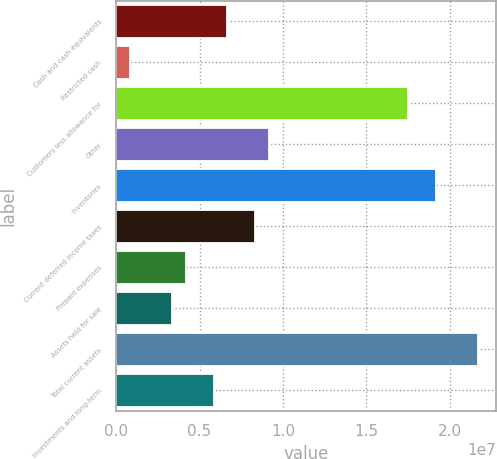Convert chart. <chart><loc_0><loc_0><loc_500><loc_500><bar_chart><fcel>Cash and cash equivalents<fcel>Restricted cash<fcel>Customers less allowance for<fcel>Other<fcel>Inventories<fcel>Current deferred income taxes<fcel>Prepaid expenses<fcel>Assets held for sale<fcel>Total current assets<fcel>Investments and long-term<nl><fcel>6.67165e+06<fcel>834058<fcel>1.75129e+07<fcel>9.17348e+06<fcel>1.91808e+07<fcel>8.33954e+06<fcel>4.16983e+06<fcel>3.33588e+06<fcel>2.16826e+07<fcel>5.83771e+06<nl></chart> 